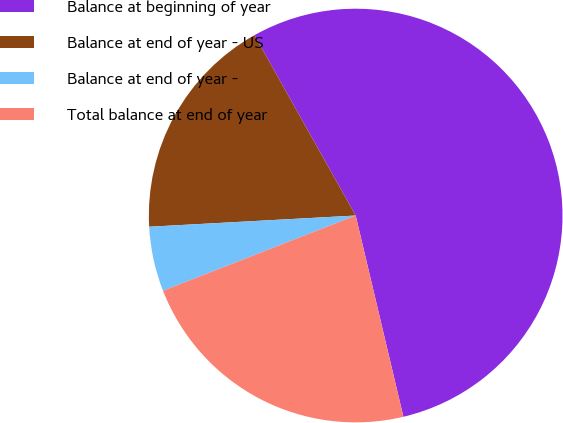Convert chart to OTSL. <chart><loc_0><loc_0><loc_500><loc_500><pie_chart><fcel>Balance at beginning of year<fcel>Balance at end of year - US<fcel>Balance at end of year -<fcel>Total balance at end of year<nl><fcel>54.43%<fcel>17.72%<fcel>5.06%<fcel>22.78%<nl></chart> 